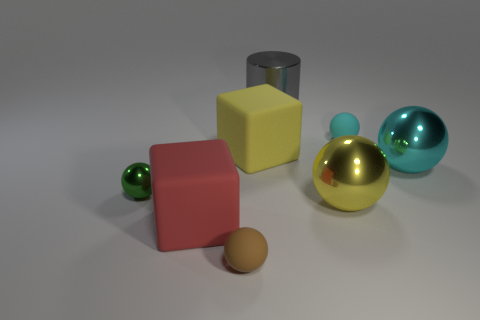How many cylinders are either big gray metal objects or small cyan objects?
Offer a terse response. 1. What number of large objects are both to the right of the big red thing and in front of the gray metal cylinder?
Your answer should be very brief. 3. There is a yellow sphere; is it the same size as the rubber ball behind the brown rubber thing?
Your response must be concise. No. Are there any shiny things that are to the left of the large rubber block that is behind the big yellow object that is in front of the small green metal thing?
Provide a short and direct response. Yes. What is the cyan thing in front of the large yellow matte block that is in front of the gray cylinder made of?
Keep it short and to the point. Metal. There is a small object that is both right of the green thing and left of the tiny cyan rubber thing; what is its material?
Offer a very short reply. Rubber. Is there a large blue metallic object of the same shape as the big yellow rubber thing?
Your answer should be very brief. No. Is there a metallic cylinder that is on the right side of the small object that is on the right side of the large gray cylinder?
Make the answer very short. No. What number of tiny green things have the same material as the small cyan sphere?
Offer a very short reply. 0. Is there a large gray ball?
Provide a short and direct response. No. 